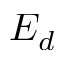Convert formula to latex. <formula><loc_0><loc_0><loc_500><loc_500>E _ { d }</formula> 